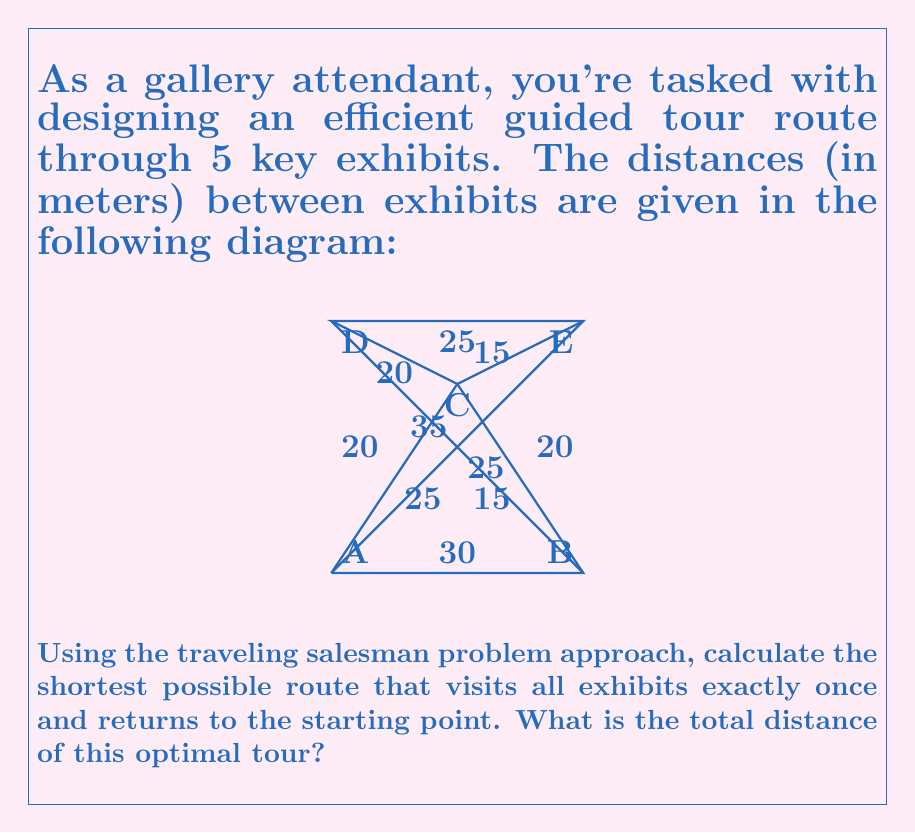Can you solve this math problem? To solve this traveling salesman problem, we'll use the nearest neighbor heuristic as an approximation method. While this doesn't guarantee the optimal solution, it's a good starting point for small problems like this.

Step 1: Choose a starting point. Let's start at exhibit A.

Step 2: Find the nearest unvisited exhibit and move to it. Repeat until all exhibits are visited.

From A:
- Nearest is D (20m)
From D:
- Nearest unvisited is C (20m)
From C:
- Nearest unvisited is E (15m)
From E:
- Only B is left (20m)
From B:
- Return to A (30m)

Step 3: Calculate the total distance:
$$\text{Total distance} = 20 + 20 + 15 + 20 + 30 = 105\text{ meters}$$

Step 4: Check if any simple swaps improve the solution.
Current order: A - D - C - E - B - A
Possible swaps:
1. D and C: A - C - D - E - B - A = 25 + 20 + 25 + 20 + 30 = 120m (worse)
2. C and E: A - D - E - C - B - A = 20 + 25 + 15 + 15 + 30 = 105m (same)
3. E and B: A - D - C - B - E - A = 20 + 20 + 15 + 20 + 35 = 110m (worse)

No improvement found, so our heuristic solution stands.

Note: This heuristic method doesn't guarantee the optimal solution for all TSP instances, but it provides a good approximation for this small problem.
Answer: 105 meters 